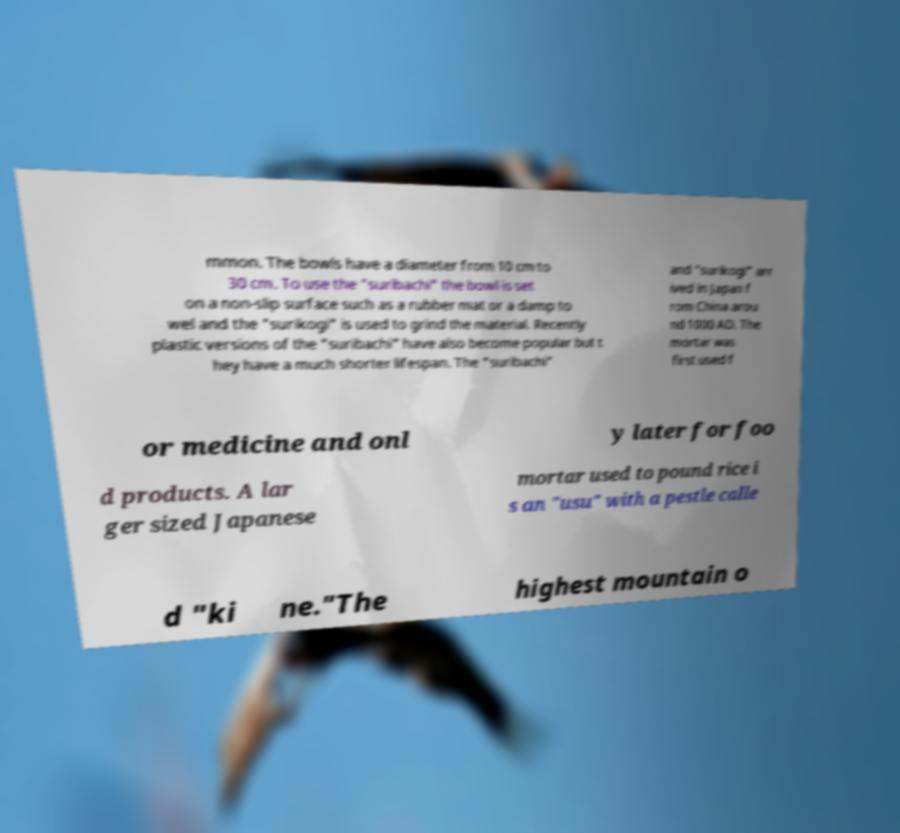Could you assist in decoding the text presented in this image and type it out clearly? mmon. The bowls have a diameter from 10 cm to 30 cm. To use the "suribachi" the bowl is set on a non-slip surface such as a rubber mat or a damp to wel and the "surikogi" is used to grind the material. Recently plastic versions of the "suribachi" have also become popular but t hey have a much shorter lifespan. The "suribachi" and "surikogi" arr ived in Japan f rom China arou nd 1000 AD. The mortar was first used f or medicine and onl y later for foo d products. A lar ger sized Japanese mortar used to pound rice i s an "usu" with a pestle calle d "ki ne."The highest mountain o 